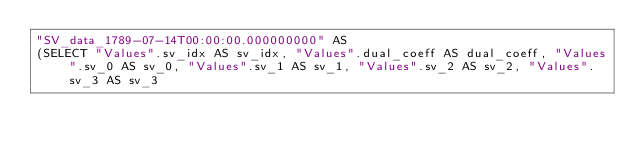<code> <loc_0><loc_0><loc_500><loc_500><_SQL_>"SV_data_1789-07-14T00:00:00.000000000" AS 
(SELECT "Values".sv_idx AS sv_idx, "Values".dual_coeff AS dual_coeff, "Values".sv_0 AS sv_0, "Values".sv_1 AS sv_1, "Values".sv_2 AS sv_2, "Values".sv_3 AS sv_3 </code> 